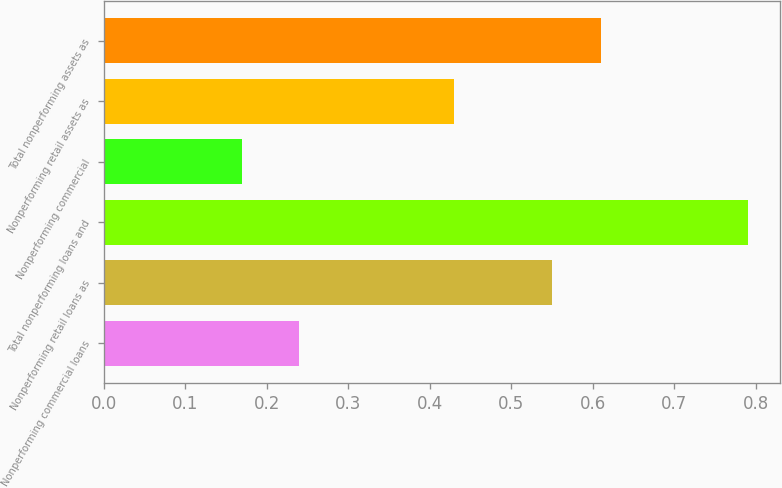Convert chart. <chart><loc_0><loc_0><loc_500><loc_500><bar_chart><fcel>Nonperforming commercial loans<fcel>Nonperforming retail loans as<fcel>Total nonperforming loans and<fcel>Nonperforming commercial<fcel>Nonperforming retail assets as<fcel>Total nonperforming assets as<nl><fcel>0.24<fcel>0.55<fcel>0.79<fcel>0.17<fcel>0.43<fcel>0.61<nl></chart> 